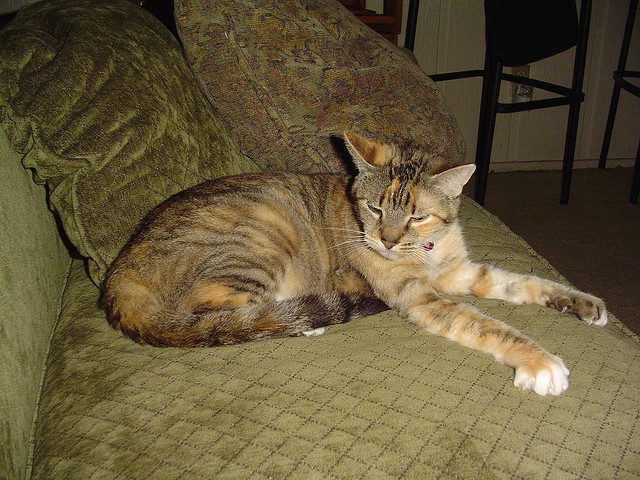Describe the objects in this image and their specific colors. I can see couch in black and olive tones, cat in black, tan, olive, and gray tones, chair in black, darkgreen, and gray tones, and chair in black tones in this image. 